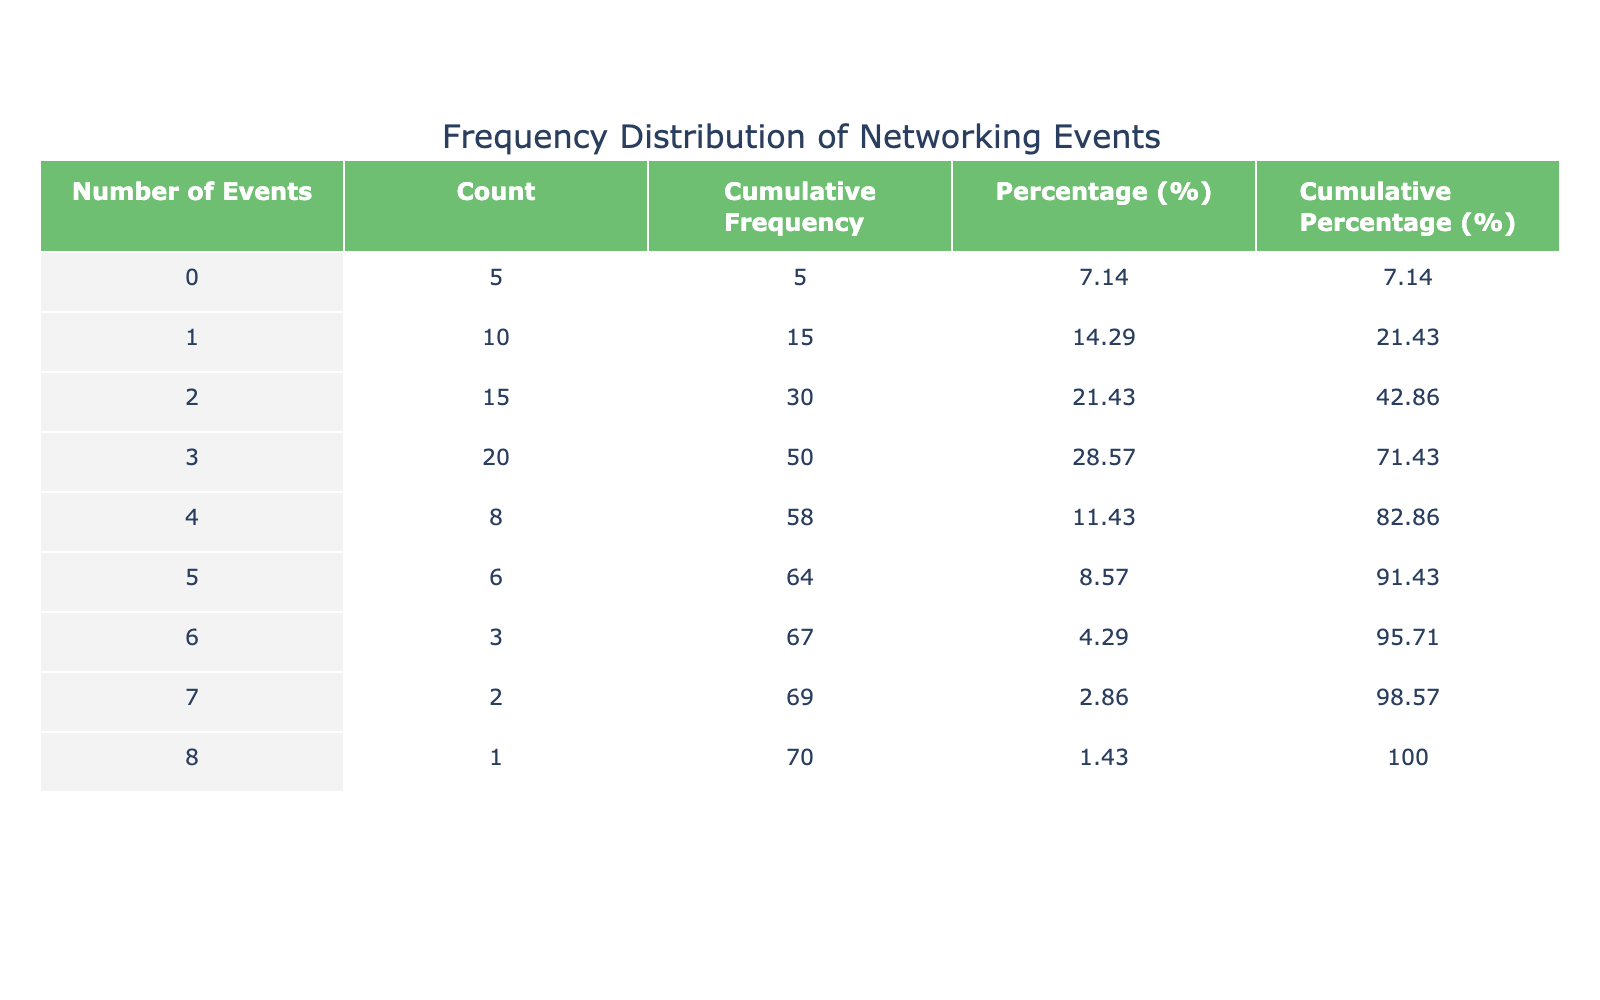What is the total number of networking events attended by law school graduates? To find the total number of networking events attended, I need to multiply the number of events by the respective count and then sum all those products. So, (0 * 5) + (1 * 10) + (2 * 15) + (3 * 20) + (4 * 8) + (5 * 6) + (6 * 3) + (7 * 2) + (8 * 1) = 0 + 10 + 30 + 60 + 32 + 30 + 18 + 14 + 8 = 172.
Answer: 172 How many graduates attended 3 networking events? The table indicates the count for graduates who attended 3 events is 20.
Answer: 20 What percentage of graduates attended 0 networking events? To find the percentage, I take the count of graduates who attended 0 events (5) and divide it by the total number of graduates (which is 5 + 10 + 15 + 20 + 8 + 6 + 3 + 2 + 1 = 70) and then multiply by 100. So, (5/70) * 100 = 7.14%.
Answer: 7.14 Is the cumulative percentage of graduates attending 5 events greater than 50%? The cumulative percentage for attending 5 events combines the percentages of those who attended 0 to 5 events. Adding those percentages gives me 7.14 + 14.29 + 21.43 + 28.57 + 11.43 + 8.57 = 91.43%. Since 91.43% is greater than 50%, the answer is yes.
Answer: Yes What is the average number of networking events attended by graduates? To calculate the average, I divide the total number of events attended (172) by the total count of graduates (70). So, 172/70 ≈ 2.46 events per graduate.
Answer: 2.46 How many graduates attended 4 or more networking events? To find out how many attended 4 or more events, I sum the counts of those who attended 4 events (8), 5 events (6), 6 events (3), 7 events (2), and 8 events (1): 8 + 6 + 3 + 2 + 1 = 20.
Answer: 20 What is the difference in count between graduates who attended 2 events and those who attended 6 events? The count for those who attended 2 events is 15 and for 6 events is 3. The difference is 15 - 3 = 12.
Answer: 12 What proportion of graduates attended only 1 networking event? The count of graduates who attended only 1 event is 10. The total number of graduates is 70, so the proportion is 10/70 = 0.142857, or about 14.29%.
Answer: 14.29 